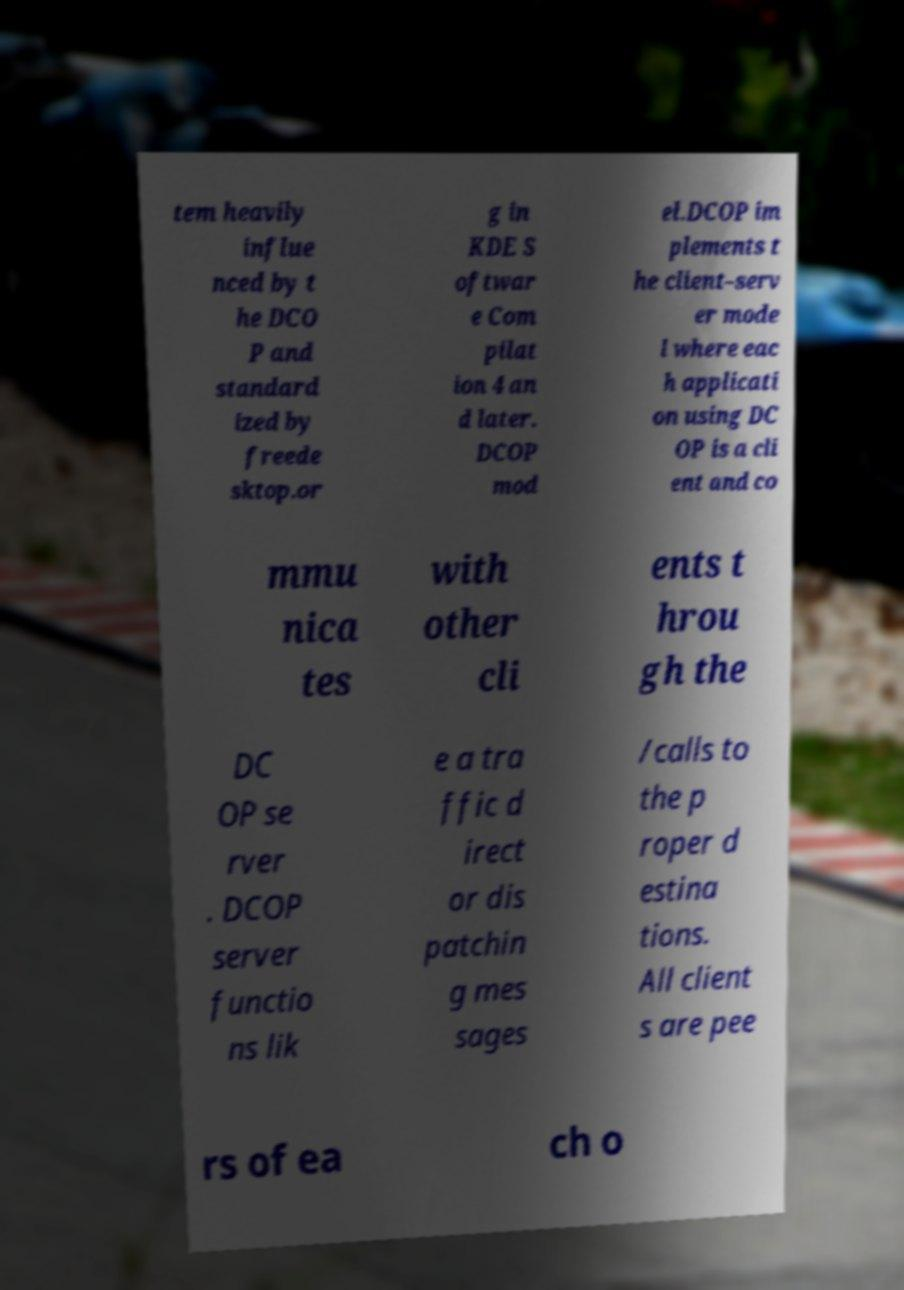Could you extract and type out the text from this image? tem heavily influe nced by t he DCO P and standard ized by freede sktop.or g in KDE S oftwar e Com pilat ion 4 an d later. DCOP mod el.DCOP im plements t he client–serv er mode l where eac h applicati on using DC OP is a cli ent and co mmu nica tes with other cli ents t hrou gh the DC OP se rver . DCOP server functio ns lik e a tra ffic d irect or dis patchin g mes sages /calls to the p roper d estina tions. All client s are pee rs of ea ch o 